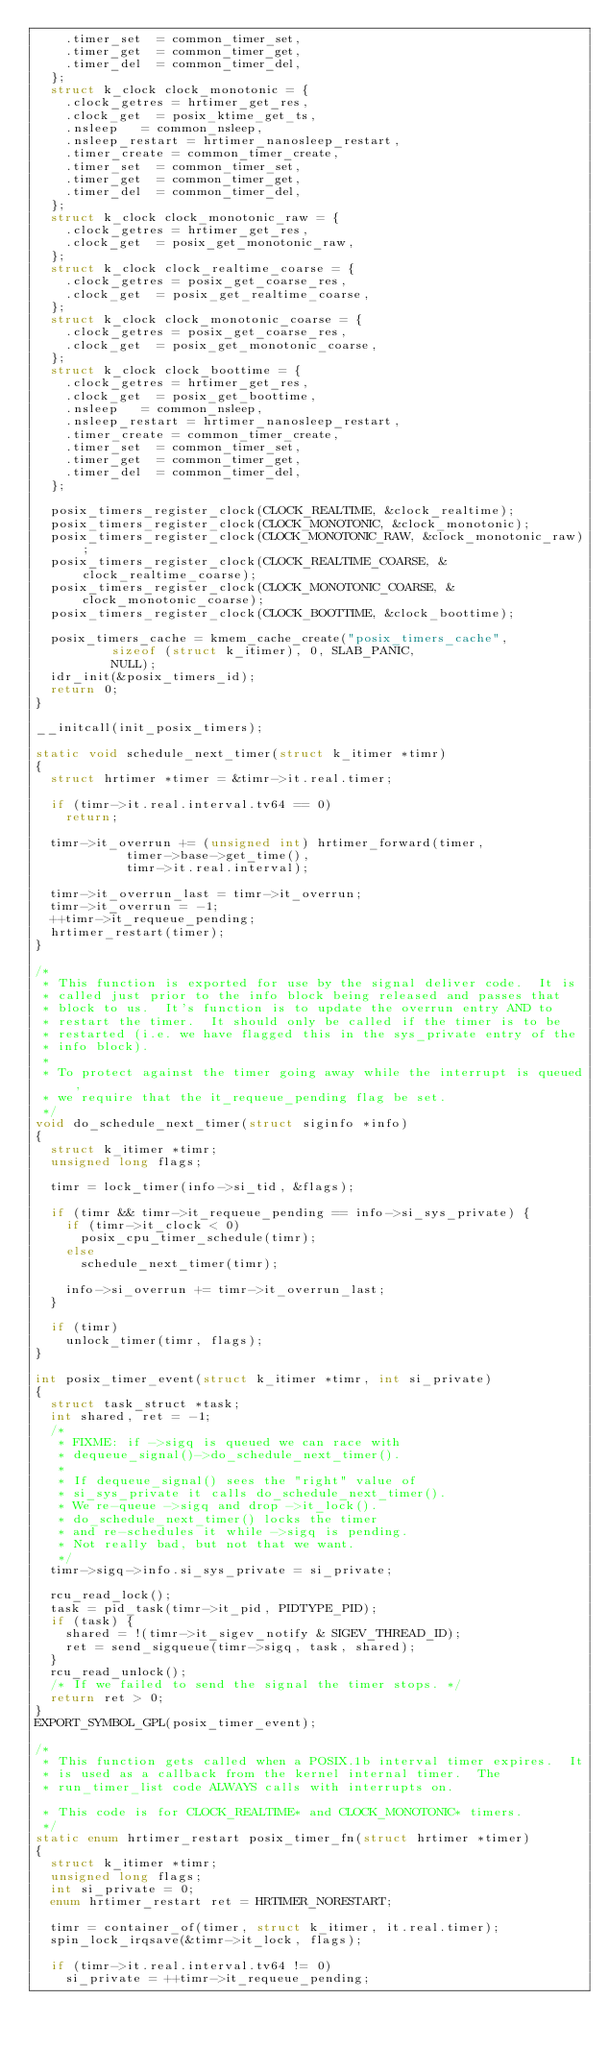Convert code to text. <code><loc_0><loc_0><loc_500><loc_500><_C_>		.timer_set	= common_timer_set,
		.timer_get	= common_timer_get,
		.timer_del	= common_timer_del,
	};
	struct k_clock clock_monotonic = {
		.clock_getres	= hrtimer_get_res,
		.clock_get	= posix_ktime_get_ts,
		.nsleep		= common_nsleep,
		.nsleep_restart	= hrtimer_nanosleep_restart,
		.timer_create	= common_timer_create,
		.timer_set	= common_timer_set,
		.timer_get	= common_timer_get,
		.timer_del	= common_timer_del,
	};
	struct k_clock clock_monotonic_raw = {
		.clock_getres	= hrtimer_get_res,
		.clock_get	= posix_get_monotonic_raw,
	};
	struct k_clock clock_realtime_coarse = {
		.clock_getres	= posix_get_coarse_res,
		.clock_get	= posix_get_realtime_coarse,
	};
	struct k_clock clock_monotonic_coarse = {
		.clock_getres	= posix_get_coarse_res,
		.clock_get	= posix_get_monotonic_coarse,
	};
	struct k_clock clock_boottime = {
		.clock_getres	= hrtimer_get_res,
		.clock_get	= posix_get_boottime,
		.nsleep		= common_nsleep,
		.nsleep_restart	= hrtimer_nanosleep_restart,
		.timer_create	= common_timer_create,
		.timer_set	= common_timer_set,
		.timer_get	= common_timer_get,
		.timer_del	= common_timer_del,
	};

	posix_timers_register_clock(CLOCK_REALTIME, &clock_realtime);
	posix_timers_register_clock(CLOCK_MONOTONIC, &clock_monotonic);
	posix_timers_register_clock(CLOCK_MONOTONIC_RAW, &clock_monotonic_raw);
	posix_timers_register_clock(CLOCK_REALTIME_COARSE, &clock_realtime_coarse);
	posix_timers_register_clock(CLOCK_MONOTONIC_COARSE, &clock_monotonic_coarse);
	posix_timers_register_clock(CLOCK_BOOTTIME, &clock_boottime);

	posix_timers_cache = kmem_cache_create("posix_timers_cache",
					sizeof (struct k_itimer), 0, SLAB_PANIC,
					NULL);
	idr_init(&posix_timers_id);
	return 0;
}

__initcall(init_posix_timers);

static void schedule_next_timer(struct k_itimer *timr)
{
	struct hrtimer *timer = &timr->it.real.timer;

	if (timr->it.real.interval.tv64 == 0)
		return;

	timr->it_overrun += (unsigned int) hrtimer_forward(timer,
						timer->base->get_time(),
						timr->it.real.interval);

	timr->it_overrun_last = timr->it_overrun;
	timr->it_overrun = -1;
	++timr->it_requeue_pending;
	hrtimer_restart(timer);
}

/*
 * This function is exported for use by the signal deliver code.  It is
 * called just prior to the info block being released and passes that
 * block to us.  It's function is to update the overrun entry AND to
 * restart the timer.  It should only be called if the timer is to be
 * restarted (i.e. we have flagged this in the sys_private entry of the
 * info block).
 *
 * To protect against the timer going away while the interrupt is queued,
 * we require that the it_requeue_pending flag be set.
 */
void do_schedule_next_timer(struct siginfo *info)
{
	struct k_itimer *timr;
	unsigned long flags;

	timr = lock_timer(info->si_tid, &flags);

	if (timr && timr->it_requeue_pending == info->si_sys_private) {
		if (timr->it_clock < 0)
			posix_cpu_timer_schedule(timr);
		else
			schedule_next_timer(timr);

		info->si_overrun += timr->it_overrun_last;
	}

	if (timr)
		unlock_timer(timr, flags);
}

int posix_timer_event(struct k_itimer *timr, int si_private)
{
	struct task_struct *task;
	int shared, ret = -1;
	/*
	 * FIXME: if ->sigq is queued we can race with
	 * dequeue_signal()->do_schedule_next_timer().
	 *
	 * If dequeue_signal() sees the "right" value of
	 * si_sys_private it calls do_schedule_next_timer().
	 * We re-queue ->sigq and drop ->it_lock().
	 * do_schedule_next_timer() locks the timer
	 * and re-schedules it while ->sigq is pending.
	 * Not really bad, but not that we want.
	 */
	timr->sigq->info.si_sys_private = si_private;

	rcu_read_lock();
	task = pid_task(timr->it_pid, PIDTYPE_PID);
	if (task) {
		shared = !(timr->it_sigev_notify & SIGEV_THREAD_ID);
		ret = send_sigqueue(timr->sigq, task, shared);
	}
	rcu_read_unlock();
	/* If we failed to send the signal the timer stops. */
	return ret > 0;
}
EXPORT_SYMBOL_GPL(posix_timer_event);

/*
 * This function gets called when a POSIX.1b interval timer expires.  It
 * is used as a callback from the kernel internal timer.  The
 * run_timer_list code ALWAYS calls with interrupts on.

 * This code is for CLOCK_REALTIME* and CLOCK_MONOTONIC* timers.
 */
static enum hrtimer_restart posix_timer_fn(struct hrtimer *timer)
{
	struct k_itimer *timr;
	unsigned long flags;
	int si_private = 0;
	enum hrtimer_restart ret = HRTIMER_NORESTART;

	timr = container_of(timer, struct k_itimer, it.real.timer);
	spin_lock_irqsave(&timr->it_lock, flags);

	if (timr->it.real.interval.tv64 != 0)
		si_private = ++timr->it_requeue_pending;
</code> 